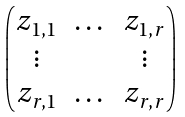<formula> <loc_0><loc_0><loc_500><loc_500>\begin{pmatrix} z _ { 1 , 1 } & \dots & z _ { 1 , r } \\ \vdots & & \vdots \\ z _ { r , 1 } & \dots & z _ { r , r } \end{pmatrix}</formula> 